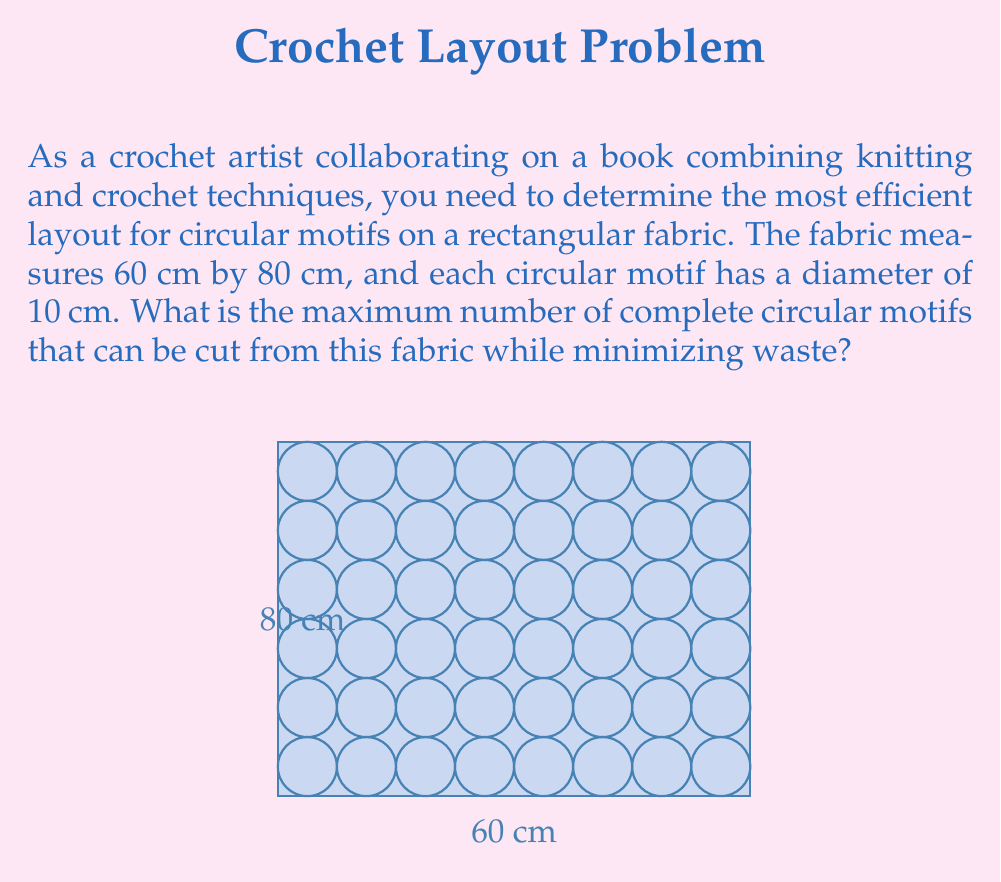What is the answer to this math problem? To solve this problem, we'll follow these steps:

1) First, we need to determine the most efficient arrangement of circles on the rectangle. The optimal arrangement is a grid pattern.

2) Calculate how many circles can fit along the length:
   $$ \text{Circles along length} = \left\lfloor\frac{80\text{ cm}}{10\text{ cm}}\right\rfloor = 8 $$

3) Calculate how many circles can fit along the width:
   $$ \text{Circles along width} = \left\lfloor\frac{60\text{ cm}}{10\text{ cm}}\right\rfloor = 6 $$

4) The total number of circles is the product of circles along length and width:
   $$ \text{Total circles} = 8 \times 6 = 48 $$

This arrangement leaves some waste around the edges, but it's the most efficient way to cut complete circles from the rectangular fabric.
Answer: 48 circular motifs 